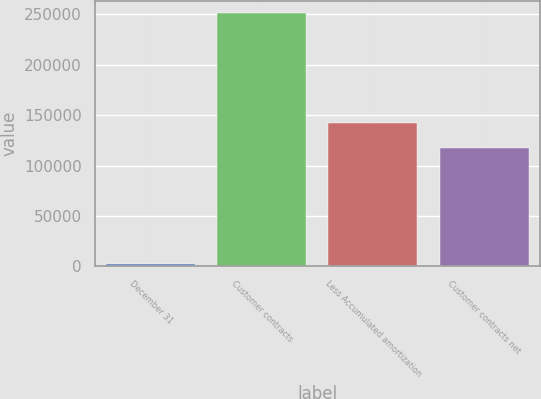<chart> <loc_0><loc_0><loc_500><loc_500><bar_chart><fcel>December 31<fcel>Customer contracts<fcel>Less Accumulated amortization<fcel>Customer contracts net<nl><fcel>2016<fcel>251194<fcel>142384<fcel>117466<nl></chart> 